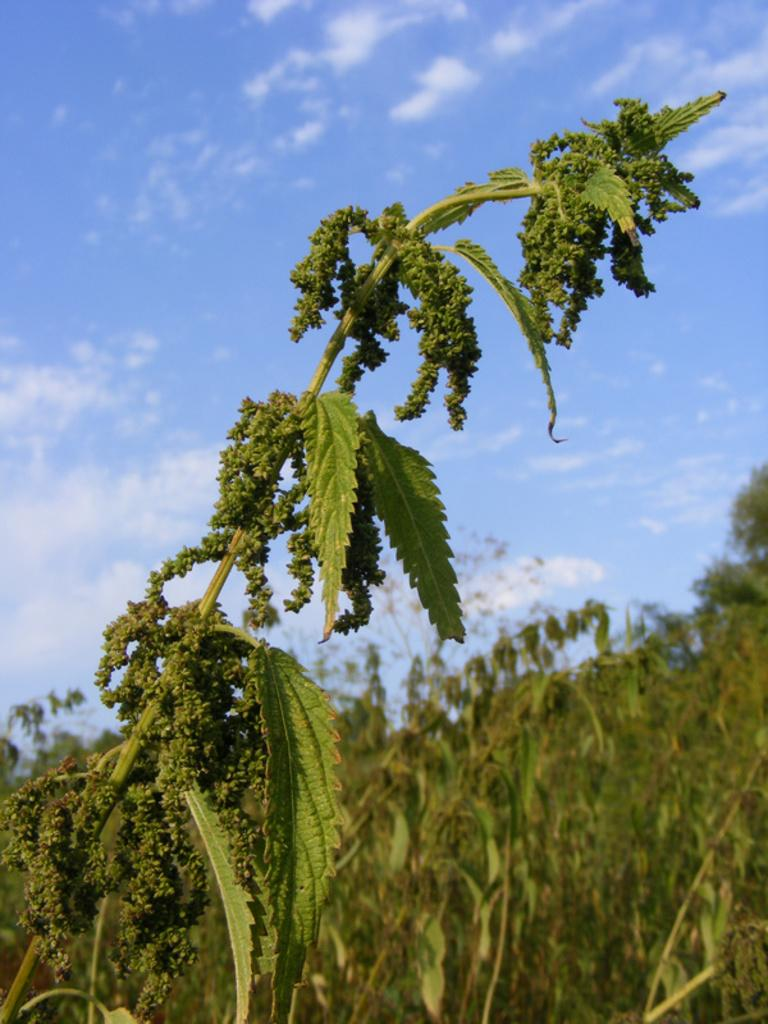What is present in the picture? There is a plant in the picture. What specific part of the plant can be seen? The plant has leaves. What can be seen in the background of the picture? There are trees in the background of the picture. What type of bomb is hanging from the plant in the image? There is no bomb present in the image; it features a plant with leaves and trees in the background. 